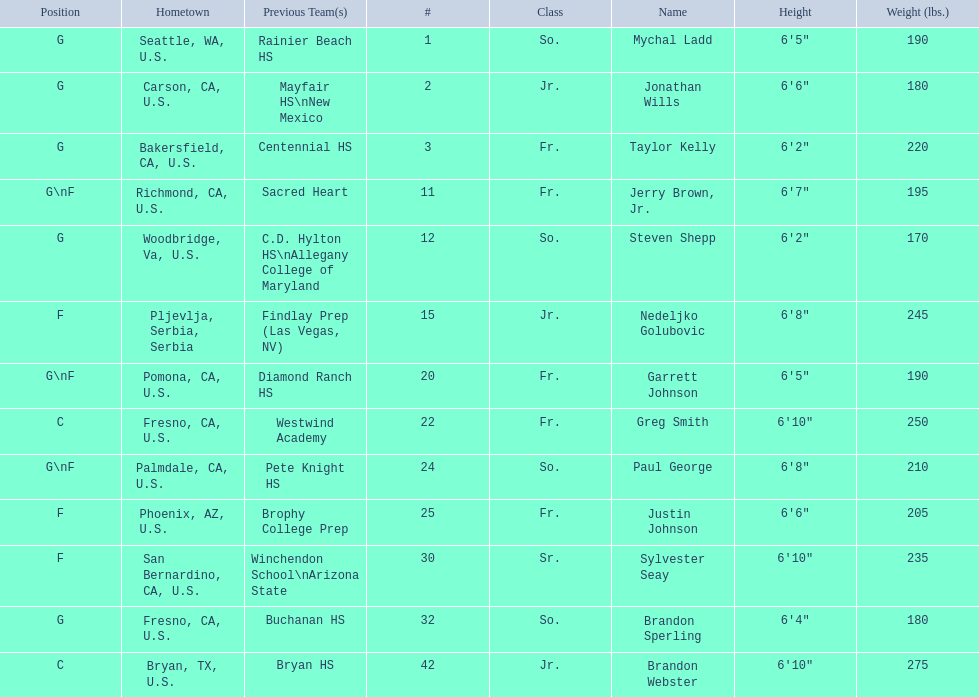Which positions are so.? G, G, G\nF, G. Which weights are g 190, 170, 180. What height is under 6 3' 6'2". What is the name Steven Shepp. 